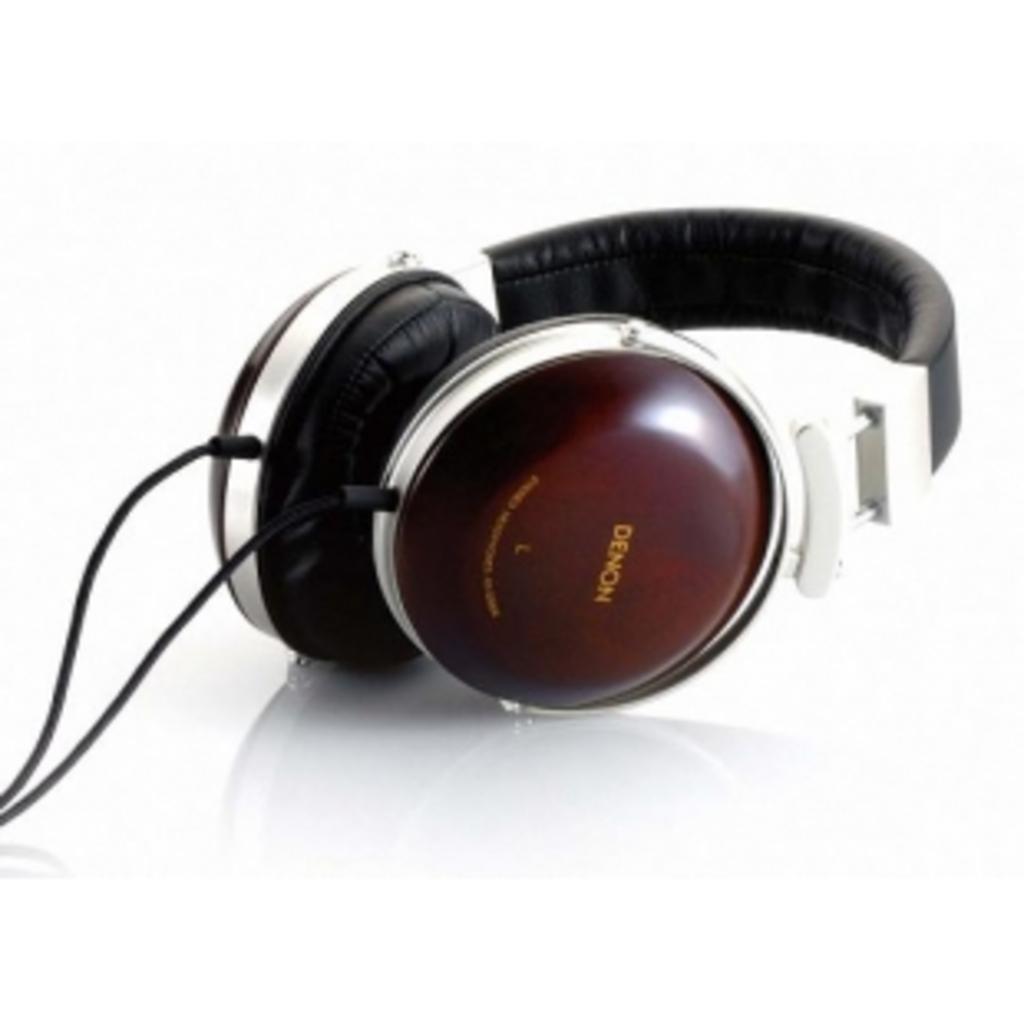How would you summarize this image in a sentence or two? There is a wired headset which is in brown and black colour placed on the white floor. 